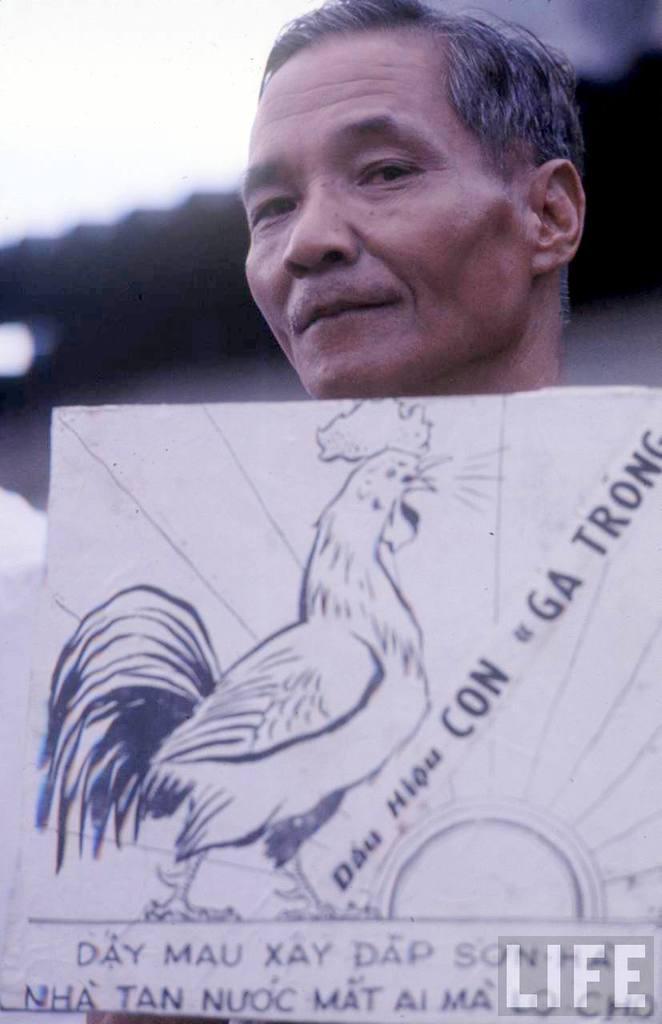Could you give a brief overview of what you see in this image? In this image, we can see an old man. At the bottom, there is a board. Some text and hen sketch on the it. Background there is a blur view. 